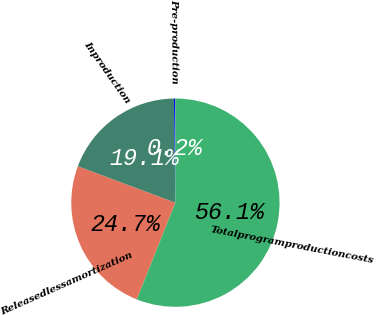Convert chart to OTSL. <chart><loc_0><loc_0><loc_500><loc_500><pie_chart><fcel>Releasedlessamortization<fcel>Inproduction<fcel>Pre-production<fcel>Totalprogramproductioncosts<nl><fcel>24.66%<fcel>19.08%<fcel>0.2%<fcel>56.06%<nl></chart> 